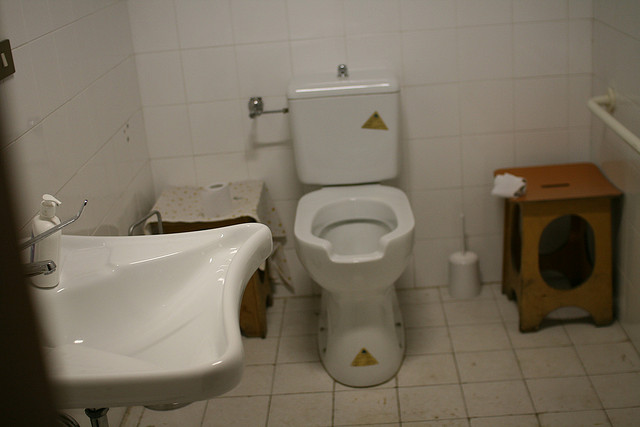<image>What is the purpose of the thing attached to the toilet? I am not sure about the purpose of the thing attached to the toilet. It might hold water or could be used for flushing. What is the silver bar for? I am not sure what the silver bar is for. It could be for toilet paper or towels or something related to flushing or plumbing. What color is the tissue box on the counter? There is no tissue box on the counter in the image. What does the sign say? It is ambiguous what the sign says. The answers range from 'caution', 'yield', 'warning' to 'don't remove'. What is the purpose of the thing attached to the toilet? I am not sure about the purpose of the thing attached to the toilet. However, it could be used to flush the toilet or hold water. What is the silver bar for? I don't know what the silver bar is for. It can be used for holding toilet paper or towels. What color is the tissue box on the counter? There is a tissue box on the counter. It is either white, brown or it may not have a tissue box at all. What does the sign say? It says either 'caution', 'yield', 'warning', or 'nothing'. 